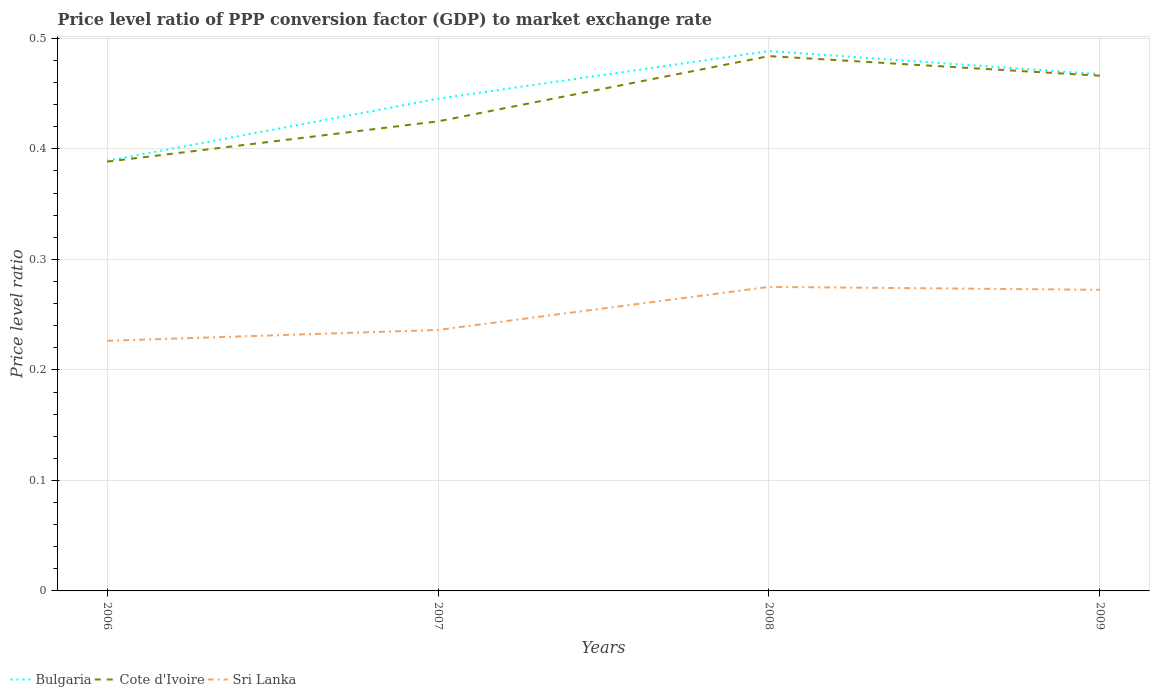Is the number of lines equal to the number of legend labels?
Offer a terse response. Yes. Across all years, what is the maximum price level ratio in Cote d'Ivoire?
Provide a short and direct response. 0.39. What is the total price level ratio in Bulgaria in the graph?
Provide a short and direct response. -0.1. What is the difference between the highest and the second highest price level ratio in Cote d'Ivoire?
Offer a very short reply. 0.1. What is the difference between the highest and the lowest price level ratio in Bulgaria?
Provide a succinct answer. 2. How many years are there in the graph?
Make the answer very short. 4. What is the difference between two consecutive major ticks on the Y-axis?
Your response must be concise. 0.1. Where does the legend appear in the graph?
Offer a very short reply. Bottom left. What is the title of the graph?
Offer a very short reply. Price level ratio of PPP conversion factor (GDP) to market exchange rate. What is the label or title of the Y-axis?
Keep it short and to the point. Price level ratio. What is the Price level ratio in Bulgaria in 2006?
Your answer should be very brief. 0.39. What is the Price level ratio in Cote d'Ivoire in 2006?
Ensure brevity in your answer.  0.39. What is the Price level ratio of Sri Lanka in 2006?
Your answer should be very brief. 0.23. What is the Price level ratio in Bulgaria in 2007?
Give a very brief answer. 0.45. What is the Price level ratio of Cote d'Ivoire in 2007?
Make the answer very short. 0.42. What is the Price level ratio of Sri Lanka in 2007?
Provide a succinct answer. 0.24. What is the Price level ratio in Bulgaria in 2008?
Make the answer very short. 0.49. What is the Price level ratio in Cote d'Ivoire in 2008?
Give a very brief answer. 0.48. What is the Price level ratio in Sri Lanka in 2008?
Offer a terse response. 0.28. What is the Price level ratio of Bulgaria in 2009?
Your response must be concise. 0.47. What is the Price level ratio of Cote d'Ivoire in 2009?
Your answer should be very brief. 0.47. What is the Price level ratio in Sri Lanka in 2009?
Ensure brevity in your answer.  0.27. Across all years, what is the maximum Price level ratio of Bulgaria?
Offer a very short reply. 0.49. Across all years, what is the maximum Price level ratio in Cote d'Ivoire?
Your response must be concise. 0.48. Across all years, what is the maximum Price level ratio of Sri Lanka?
Your answer should be compact. 0.28. Across all years, what is the minimum Price level ratio in Bulgaria?
Offer a terse response. 0.39. Across all years, what is the minimum Price level ratio in Cote d'Ivoire?
Offer a terse response. 0.39. Across all years, what is the minimum Price level ratio of Sri Lanka?
Your answer should be compact. 0.23. What is the total Price level ratio in Bulgaria in the graph?
Your answer should be very brief. 1.79. What is the total Price level ratio of Cote d'Ivoire in the graph?
Ensure brevity in your answer.  1.76. What is the difference between the Price level ratio in Bulgaria in 2006 and that in 2007?
Ensure brevity in your answer.  -0.06. What is the difference between the Price level ratio of Cote d'Ivoire in 2006 and that in 2007?
Offer a terse response. -0.04. What is the difference between the Price level ratio in Sri Lanka in 2006 and that in 2007?
Give a very brief answer. -0.01. What is the difference between the Price level ratio of Bulgaria in 2006 and that in 2008?
Offer a very short reply. -0.1. What is the difference between the Price level ratio of Cote d'Ivoire in 2006 and that in 2008?
Provide a short and direct response. -0.1. What is the difference between the Price level ratio of Sri Lanka in 2006 and that in 2008?
Keep it short and to the point. -0.05. What is the difference between the Price level ratio of Bulgaria in 2006 and that in 2009?
Your response must be concise. -0.08. What is the difference between the Price level ratio of Cote d'Ivoire in 2006 and that in 2009?
Your answer should be compact. -0.08. What is the difference between the Price level ratio in Sri Lanka in 2006 and that in 2009?
Ensure brevity in your answer.  -0.05. What is the difference between the Price level ratio of Bulgaria in 2007 and that in 2008?
Offer a very short reply. -0.04. What is the difference between the Price level ratio in Cote d'Ivoire in 2007 and that in 2008?
Your response must be concise. -0.06. What is the difference between the Price level ratio of Sri Lanka in 2007 and that in 2008?
Your response must be concise. -0.04. What is the difference between the Price level ratio of Bulgaria in 2007 and that in 2009?
Your answer should be compact. -0.02. What is the difference between the Price level ratio of Cote d'Ivoire in 2007 and that in 2009?
Your answer should be compact. -0.04. What is the difference between the Price level ratio of Sri Lanka in 2007 and that in 2009?
Your answer should be very brief. -0.04. What is the difference between the Price level ratio of Bulgaria in 2008 and that in 2009?
Keep it short and to the point. 0.02. What is the difference between the Price level ratio of Cote d'Ivoire in 2008 and that in 2009?
Make the answer very short. 0.02. What is the difference between the Price level ratio of Sri Lanka in 2008 and that in 2009?
Provide a succinct answer. 0. What is the difference between the Price level ratio in Bulgaria in 2006 and the Price level ratio in Cote d'Ivoire in 2007?
Your answer should be compact. -0.04. What is the difference between the Price level ratio of Bulgaria in 2006 and the Price level ratio of Sri Lanka in 2007?
Your answer should be very brief. 0.15. What is the difference between the Price level ratio in Cote d'Ivoire in 2006 and the Price level ratio in Sri Lanka in 2007?
Your response must be concise. 0.15. What is the difference between the Price level ratio in Bulgaria in 2006 and the Price level ratio in Cote d'Ivoire in 2008?
Provide a succinct answer. -0.09. What is the difference between the Price level ratio in Bulgaria in 2006 and the Price level ratio in Sri Lanka in 2008?
Offer a very short reply. 0.11. What is the difference between the Price level ratio in Cote d'Ivoire in 2006 and the Price level ratio in Sri Lanka in 2008?
Make the answer very short. 0.11. What is the difference between the Price level ratio of Bulgaria in 2006 and the Price level ratio of Cote d'Ivoire in 2009?
Offer a very short reply. -0.08. What is the difference between the Price level ratio in Bulgaria in 2006 and the Price level ratio in Sri Lanka in 2009?
Offer a very short reply. 0.12. What is the difference between the Price level ratio in Cote d'Ivoire in 2006 and the Price level ratio in Sri Lanka in 2009?
Make the answer very short. 0.12. What is the difference between the Price level ratio of Bulgaria in 2007 and the Price level ratio of Cote d'Ivoire in 2008?
Give a very brief answer. -0.04. What is the difference between the Price level ratio of Bulgaria in 2007 and the Price level ratio of Sri Lanka in 2008?
Make the answer very short. 0.17. What is the difference between the Price level ratio in Cote d'Ivoire in 2007 and the Price level ratio in Sri Lanka in 2008?
Give a very brief answer. 0.15. What is the difference between the Price level ratio in Bulgaria in 2007 and the Price level ratio in Cote d'Ivoire in 2009?
Offer a terse response. -0.02. What is the difference between the Price level ratio in Bulgaria in 2007 and the Price level ratio in Sri Lanka in 2009?
Keep it short and to the point. 0.17. What is the difference between the Price level ratio of Cote d'Ivoire in 2007 and the Price level ratio of Sri Lanka in 2009?
Ensure brevity in your answer.  0.15. What is the difference between the Price level ratio of Bulgaria in 2008 and the Price level ratio of Cote d'Ivoire in 2009?
Make the answer very short. 0.02. What is the difference between the Price level ratio in Bulgaria in 2008 and the Price level ratio in Sri Lanka in 2009?
Offer a terse response. 0.22. What is the difference between the Price level ratio of Cote d'Ivoire in 2008 and the Price level ratio of Sri Lanka in 2009?
Your answer should be compact. 0.21. What is the average Price level ratio of Bulgaria per year?
Offer a terse response. 0.45. What is the average Price level ratio in Cote d'Ivoire per year?
Ensure brevity in your answer.  0.44. What is the average Price level ratio of Sri Lanka per year?
Provide a succinct answer. 0.25. In the year 2006, what is the difference between the Price level ratio in Bulgaria and Price level ratio in Cote d'Ivoire?
Give a very brief answer. 0. In the year 2006, what is the difference between the Price level ratio of Bulgaria and Price level ratio of Sri Lanka?
Make the answer very short. 0.16. In the year 2006, what is the difference between the Price level ratio in Cote d'Ivoire and Price level ratio in Sri Lanka?
Ensure brevity in your answer.  0.16. In the year 2007, what is the difference between the Price level ratio of Bulgaria and Price level ratio of Cote d'Ivoire?
Offer a terse response. 0.02. In the year 2007, what is the difference between the Price level ratio in Bulgaria and Price level ratio in Sri Lanka?
Offer a very short reply. 0.21. In the year 2007, what is the difference between the Price level ratio in Cote d'Ivoire and Price level ratio in Sri Lanka?
Provide a succinct answer. 0.19. In the year 2008, what is the difference between the Price level ratio in Bulgaria and Price level ratio in Cote d'Ivoire?
Provide a succinct answer. 0. In the year 2008, what is the difference between the Price level ratio in Bulgaria and Price level ratio in Sri Lanka?
Make the answer very short. 0.21. In the year 2008, what is the difference between the Price level ratio in Cote d'Ivoire and Price level ratio in Sri Lanka?
Your answer should be very brief. 0.21. In the year 2009, what is the difference between the Price level ratio in Bulgaria and Price level ratio in Cote d'Ivoire?
Make the answer very short. 0. In the year 2009, what is the difference between the Price level ratio in Bulgaria and Price level ratio in Sri Lanka?
Ensure brevity in your answer.  0.2. In the year 2009, what is the difference between the Price level ratio of Cote d'Ivoire and Price level ratio of Sri Lanka?
Your response must be concise. 0.19. What is the ratio of the Price level ratio of Bulgaria in 2006 to that in 2007?
Ensure brevity in your answer.  0.87. What is the ratio of the Price level ratio of Cote d'Ivoire in 2006 to that in 2007?
Provide a short and direct response. 0.91. What is the ratio of the Price level ratio of Sri Lanka in 2006 to that in 2007?
Keep it short and to the point. 0.96. What is the ratio of the Price level ratio in Bulgaria in 2006 to that in 2008?
Provide a short and direct response. 0.8. What is the ratio of the Price level ratio of Cote d'Ivoire in 2006 to that in 2008?
Your answer should be compact. 0.8. What is the ratio of the Price level ratio in Sri Lanka in 2006 to that in 2008?
Provide a short and direct response. 0.82. What is the ratio of the Price level ratio in Bulgaria in 2006 to that in 2009?
Your answer should be compact. 0.83. What is the ratio of the Price level ratio in Cote d'Ivoire in 2006 to that in 2009?
Provide a short and direct response. 0.83. What is the ratio of the Price level ratio of Sri Lanka in 2006 to that in 2009?
Your answer should be very brief. 0.83. What is the ratio of the Price level ratio in Bulgaria in 2007 to that in 2008?
Your response must be concise. 0.91. What is the ratio of the Price level ratio in Cote d'Ivoire in 2007 to that in 2008?
Make the answer very short. 0.88. What is the ratio of the Price level ratio of Sri Lanka in 2007 to that in 2008?
Offer a very short reply. 0.86. What is the ratio of the Price level ratio of Bulgaria in 2007 to that in 2009?
Give a very brief answer. 0.95. What is the ratio of the Price level ratio in Cote d'Ivoire in 2007 to that in 2009?
Give a very brief answer. 0.91. What is the ratio of the Price level ratio in Sri Lanka in 2007 to that in 2009?
Your response must be concise. 0.87. What is the ratio of the Price level ratio of Bulgaria in 2008 to that in 2009?
Your answer should be compact. 1.04. What is the ratio of the Price level ratio in Cote d'Ivoire in 2008 to that in 2009?
Keep it short and to the point. 1.04. What is the ratio of the Price level ratio of Sri Lanka in 2008 to that in 2009?
Provide a succinct answer. 1.01. What is the difference between the highest and the second highest Price level ratio of Bulgaria?
Provide a short and direct response. 0.02. What is the difference between the highest and the second highest Price level ratio of Cote d'Ivoire?
Give a very brief answer. 0.02. What is the difference between the highest and the second highest Price level ratio of Sri Lanka?
Give a very brief answer. 0. What is the difference between the highest and the lowest Price level ratio of Bulgaria?
Make the answer very short. 0.1. What is the difference between the highest and the lowest Price level ratio in Cote d'Ivoire?
Give a very brief answer. 0.1. What is the difference between the highest and the lowest Price level ratio in Sri Lanka?
Your response must be concise. 0.05. 